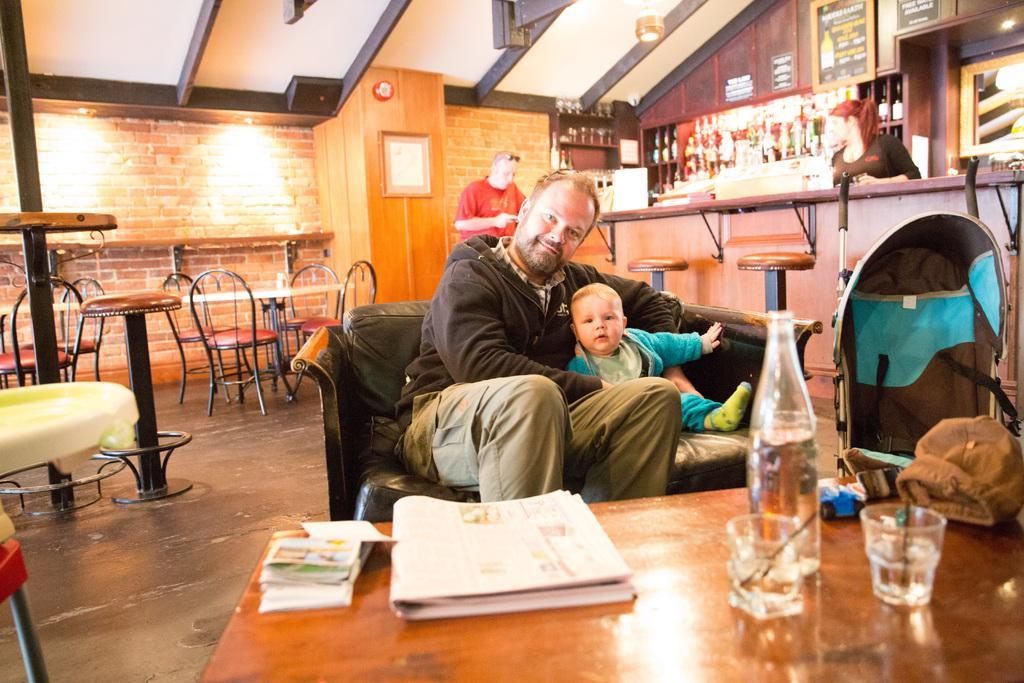In one or two sentences, can you explain what this image depicts? In the given image we can see there are four people and there are many chairs and table. On the table we can see a glass and a bottle. There are many bottles on the shelf. 